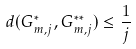Convert formula to latex. <formula><loc_0><loc_0><loc_500><loc_500>d ( G ^ { * } _ { m , j } , G ^ { * * } _ { m , j } ) \leq \frac { 1 } { j }</formula> 